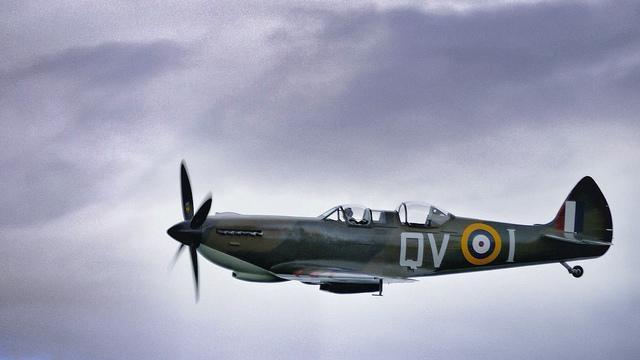How many airplanes are there?
Give a very brief answer. 1. 